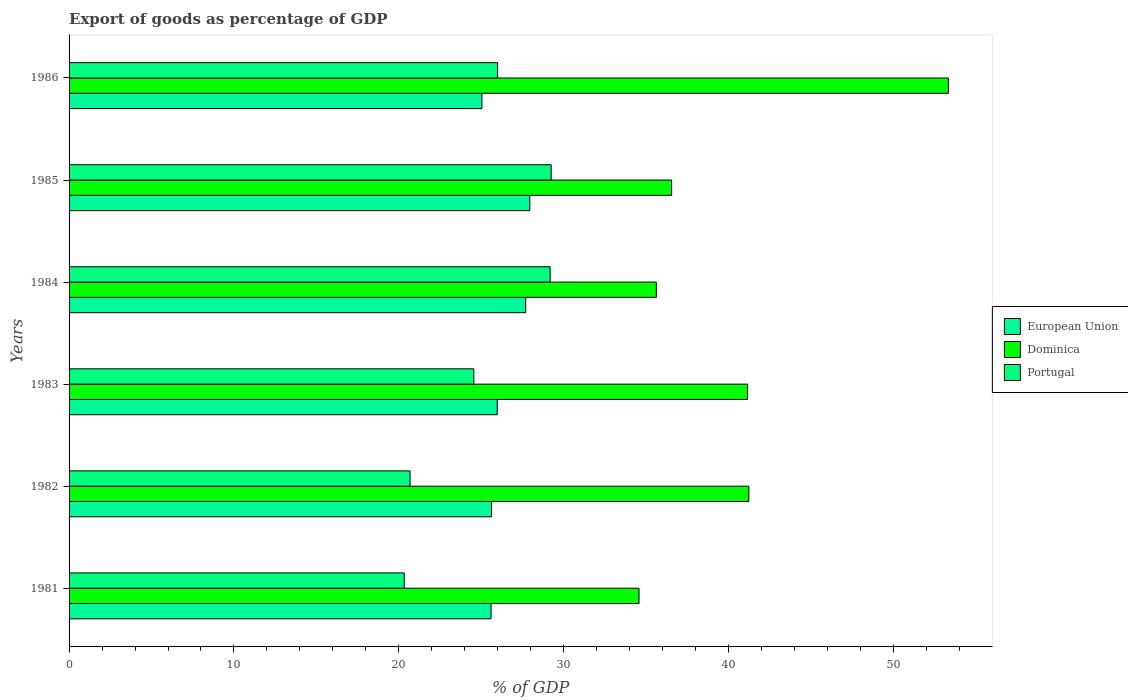How many groups of bars are there?
Your answer should be very brief. 6. Are the number of bars per tick equal to the number of legend labels?
Provide a short and direct response. Yes. Are the number of bars on each tick of the Y-axis equal?
Give a very brief answer. Yes. What is the export of goods as percentage of GDP in Dominica in 1981?
Provide a succinct answer. 34.57. Across all years, what is the maximum export of goods as percentage of GDP in Dominica?
Your response must be concise. 53.33. Across all years, what is the minimum export of goods as percentage of GDP in Portugal?
Keep it short and to the point. 20.33. In which year was the export of goods as percentage of GDP in European Union maximum?
Give a very brief answer. 1985. What is the total export of goods as percentage of GDP in Dominica in the graph?
Your answer should be very brief. 242.43. What is the difference between the export of goods as percentage of GDP in European Union in 1981 and that in 1985?
Make the answer very short. -2.35. What is the difference between the export of goods as percentage of GDP in Portugal in 1985 and the export of goods as percentage of GDP in Dominica in 1983?
Give a very brief answer. -11.91. What is the average export of goods as percentage of GDP in Dominica per year?
Ensure brevity in your answer.  40.4. In the year 1986, what is the difference between the export of goods as percentage of GDP in Portugal and export of goods as percentage of GDP in Dominica?
Offer a very short reply. -27.34. What is the ratio of the export of goods as percentage of GDP in European Union in 1981 to that in 1986?
Offer a terse response. 1.02. What is the difference between the highest and the second highest export of goods as percentage of GDP in Dominica?
Keep it short and to the point. 12.1. What is the difference between the highest and the lowest export of goods as percentage of GDP in European Union?
Offer a terse response. 2.91. Is the sum of the export of goods as percentage of GDP in European Union in 1981 and 1985 greater than the maximum export of goods as percentage of GDP in Dominica across all years?
Ensure brevity in your answer.  Yes. What does the 2nd bar from the top in 1986 represents?
Provide a succinct answer. Dominica. Is it the case that in every year, the sum of the export of goods as percentage of GDP in Portugal and export of goods as percentage of GDP in Dominica is greater than the export of goods as percentage of GDP in European Union?
Offer a terse response. Yes. Are all the bars in the graph horizontal?
Your answer should be compact. Yes. How many years are there in the graph?
Keep it short and to the point. 6. What is the difference between two consecutive major ticks on the X-axis?
Keep it short and to the point. 10. Are the values on the major ticks of X-axis written in scientific E-notation?
Ensure brevity in your answer.  No. What is the title of the graph?
Make the answer very short. Export of goods as percentage of GDP. What is the label or title of the X-axis?
Offer a terse response. % of GDP. What is the % of GDP in European Union in 1981?
Your answer should be very brief. 25.59. What is the % of GDP in Dominica in 1981?
Give a very brief answer. 34.57. What is the % of GDP of Portugal in 1981?
Provide a short and direct response. 20.33. What is the % of GDP of European Union in 1982?
Offer a terse response. 25.62. What is the % of GDP in Dominica in 1982?
Offer a very short reply. 41.23. What is the % of GDP in Portugal in 1982?
Your response must be concise. 20.68. What is the % of GDP in European Union in 1983?
Your response must be concise. 25.97. What is the % of GDP in Dominica in 1983?
Your answer should be compact. 41.15. What is the % of GDP in Portugal in 1983?
Offer a terse response. 24.55. What is the % of GDP in European Union in 1984?
Your answer should be very brief. 27.69. What is the % of GDP in Dominica in 1984?
Offer a very short reply. 35.62. What is the % of GDP in Portugal in 1984?
Give a very brief answer. 29.17. What is the % of GDP in European Union in 1985?
Make the answer very short. 27.94. What is the % of GDP in Dominica in 1985?
Keep it short and to the point. 36.54. What is the % of GDP in Portugal in 1985?
Your response must be concise. 29.24. What is the % of GDP of European Union in 1986?
Your answer should be very brief. 25.04. What is the % of GDP of Dominica in 1986?
Keep it short and to the point. 53.33. What is the % of GDP of Portugal in 1986?
Your response must be concise. 25.99. Across all years, what is the maximum % of GDP of European Union?
Offer a terse response. 27.94. Across all years, what is the maximum % of GDP of Dominica?
Ensure brevity in your answer.  53.33. Across all years, what is the maximum % of GDP of Portugal?
Keep it short and to the point. 29.24. Across all years, what is the minimum % of GDP in European Union?
Make the answer very short. 25.04. Across all years, what is the minimum % of GDP in Dominica?
Provide a short and direct response. 34.57. Across all years, what is the minimum % of GDP of Portugal?
Provide a short and direct response. 20.33. What is the total % of GDP in European Union in the graph?
Your response must be concise. 157.85. What is the total % of GDP of Dominica in the graph?
Your answer should be very brief. 242.43. What is the total % of GDP in Portugal in the graph?
Offer a very short reply. 149.96. What is the difference between the % of GDP in European Union in 1981 and that in 1982?
Provide a short and direct response. -0.03. What is the difference between the % of GDP in Dominica in 1981 and that in 1982?
Provide a short and direct response. -6.66. What is the difference between the % of GDP in Portugal in 1981 and that in 1982?
Ensure brevity in your answer.  -0.35. What is the difference between the % of GDP of European Union in 1981 and that in 1983?
Offer a terse response. -0.37. What is the difference between the % of GDP in Dominica in 1981 and that in 1983?
Keep it short and to the point. -6.58. What is the difference between the % of GDP in Portugal in 1981 and that in 1983?
Ensure brevity in your answer.  -4.22. What is the difference between the % of GDP in European Union in 1981 and that in 1984?
Make the answer very short. -2.1. What is the difference between the % of GDP of Dominica in 1981 and that in 1984?
Offer a terse response. -1.05. What is the difference between the % of GDP in Portugal in 1981 and that in 1984?
Keep it short and to the point. -8.85. What is the difference between the % of GDP in European Union in 1981 and that in 1985?
Your answer should be very brief. -2.35. What is the difference between the % of GDP of Dominica in 1981 and that in 1985?
Offer a terse response. -1.98. What is the difference between the % of GDP of Portugal in 1981 and that in 1985?
Make the answer very short. -8.91. What is the difference between the % of GDP in European Union in 1981 and that in 1986?
Your answer should be very brief. 0.56. What is the difference between the % of GDP of Dominica in 1981 and that in 1986?
Ensure brevity in your answer.  -18.76. What is the difference between the % of GDP in Portugal in 1981 and that in 1986?
Offer a terse response. -5.66. What is the difference between the % of GDP in European Union in 1982 and that in 1983?
Offer a terse response. -0.35. What is the difference between the % of GDP of Dominica in 1982 and that in 1983?
Make the answer very short. 0.08. What is the difference between the % of GDP of Portugal in 1982 and that in 1983?
Make the answer very short. -3.87. What is the difference between the % of GDP in European Union in 1982 and that in 1984?
Offer a terse response. -2.07. What is the difference between the % of GDP in Dominica in 1982 and that in 1984?
Keep it short and to the point. 5.61. What is the difference between the % of GDP in Portugal in 1982 and that in 1984?
Your answer should be very brief. -8.49. What is the difference between the % of GDP in European Union in 1982 and that in 1985?
Offer a terse response. -2.32. What is the difference between the % of GDP of Dominica in 1982 and that in 1985?
Provide a short and direct response. 4.68. What is the difference between the % of GDP of Portugal in 1982 and that in 1985?
Ensure brevity in your answer.  -8.56. What is the difference between the % of GDP of European Union in 1982 and that in 1986?
Offer a very short reply. 0.59. What is the difference between the % of GDP in Dominica in 1982 and that in 1986?
Offer a terse response. -12.1. What is the difference between the % of GDP of Portugal in 1982 and that in 1986?
Offer a terse response. -5.31. What is the difference between the % of GDP in European Union in 1983 and that in 1984?
Provide a short and direct response. -1.72. What is the difference between the % of GDP of Dominica in 1983 and that in 1984?
Provide a short and direct response. 5.53. What is the difference between the % of GDP in Portugal in 1983 and that in 1984?
Provide a succinct answer. -4.63. What is the difference between the % of GDP of European Union in 1983 and that in 1985?
Offer a terse response. -1.98. What is the difference between the % of GDP of Dominica in 1983 and that in 1985?
Your response must be concise. 4.61. What is the difference between the % of GDP in Portugal in 1983 and that in 1985?
Make the answer very short. -4.69. What is the difference between the % of GDP of European Union in 1983 and that in 1986?
Your answer should be compact. 0.93. What is the difference between the % of GDP of Dominica in 1983 and that in 1986?
Provide a succinct answer. -12.18. What is the difference between the % of GDP in Portugal in 1983 and that in 1986?
Your response must be concise. -1.44. What is the difference between the % of GDP of European Union in 1984 and that in 1985?
Your answer should be very brief. -0.25. What is the difference between the % of GDP in Dominica in 1984 and that in 1985?
Give a very brief answer. -0.93. What is the difference between the % of GDP of Portugal in 1984 and that in 1985?
Your answer should be very brief. -0.06. What is the difference between the % of GDP in European Union in 1984 and that in 1986?
Give a very brief answer. 2.66. What is the difference between the % of GDP of Dominica in 1984 and that in 1986?
Provide a succinct answer. -17.71. What is the difference between the % of GDP in Portugal in 1984 and that in 1986?
Provide a succinct answer. 3.18. What is the difference between the % of GDP of European Union in 1985 and that in 1986?
Your answer should be compact. 2.91. What is the difference between the % of GDP of Dominica in 1985 and that in 1986?
Offer a very short reply. -16.78. What is the difference between the % of GDP of Portugal in 1985 and that in 1986?
Provide a short and direct response. 3.25. What is the difference between the % of GDP in European Union in 1981 and the % of GDP in Dominica in 1982?
Make the answer very short. -15.63. What is the difference between the % of GDP in European Union in 1981 and the % of GDP in Portugal in 1982?
Offer a terse response. 4.91. What is the difference between the % of GDP in Dominica in 1981 and the % of GDP in Portugal in 1982?
Your answer should be very brief. 13.89. What is the difference between the % of GDP of European Union in 1981 and the % of GDP of Dominica in 1983?
Provide a succinct answer. -15.56. What is the difference between the % of GDP in European Union in 1981 and the % of GDP in Portugal in 1983?
Offer a terse response. 1.05. What is the difference between the % of GDP of Dominica in 1981 and the % of GDP of Portugal in 1983?
Offer a terse response. 10.02. What is the difference between the % of GDP in European Union in 1981 and the % of GDP in Dominica in 1984?
Keep it short and to the point. -10.02. What is the difference between the % of GDP in European Union in 1981 and the % of GDP in Portugal in 1984?
Offer a very short reply. -3.58. What is the difference between the % of GDP in Dominica in 1981 and the % of GDP in Portugal in 1984?
Your response must be concise. 5.39. What is the difference between the % of GDP of European Union in 1981 and the % of GDP of Dominica in 1985?
Your response must be concise. -10.95. What is the difference between the % of GDP in European Union in 1981 and the % of GDP in Portugal in 1985?
Your answer should be compact. -3.64. What is the difference between the % of GDP in Dominica in 1981 and the % of GDP in Portugal in 1985?
Offer a terse response. 5.33. What is the difference between the % of GDP in European Union in 1981 and the % of GDP in Dominica in 1986?
Your answer should be compact. -27.73. What is the difference between the % of GDP in European Union in 1981 and the % of GDP in Portugal in 1986?
Keep it short and to the point. -0.4. What is the difference between the % of GDP of Dominica in 1981 and the % of GDP of Portugal in 1986?
Give a very brief answer. 8.57. What is the difference between the % of GDP in European Union in 1982 and the % of GDP in Dominica in 1983?
Give a very brief answer. -15.53. What is the difference between the % of GDP of European Union in 1982 and the % of GDP of Portugal in 1983?
Keep it short and to the point. 1.07. What is the difference between the % of GDP of Dominica in 1982 and the % of GDP of Portugal in 1983?
Your response must be concise. 16.68. What is the difference between the % of GDP in European Union in 1982 and the % of GDP in Dominica in 1984?
Keep it short and to the point. -9.99. What is the difference between the % of GDP of European Union in 1982 and the % of GDP of Portugal in 1984?
Ensure brevity in your answer.  -3.55. What is the difference between the % of GDP of Dominica in 1982 and the % of GDP of Portugal in 1984?
Your answer should be very brief. 12.05. What is the difference between the % of GDP in European Union in 1982 and the % of GDP in Dominica in 1985?
Give a very brief answer. -10.92. What is the difference between the % of GDP in European Union in 1982 and the % of GDP in Portugal in 1985?
Make the answer very short. -3.62. What is the difference between the % of GDP of Dominica in 1982 and the % of GDP of Portugal in 1985?
Make the answer very short. 11.99. What is the difference between the % of GDP in European Union in 1982 and the % of GDP in Dominica in 1986?
Your response must be concise. -27.71. What is the difference between the % of GDP of European Union in 1982 and the % of GDP of Portugal in 1986?
Your answer should be very brief. -0.37. What is the difference between the % of GDP of Dominica in 1982 and the % of GDP of Portugal in 1986?
Offer a terse response. 15.23. What is the difference between the % of GDP in European Union in 1983 and the % of GDP in Dominica in 1984?
Your answer should be compact. -9.65. What is the difference between the % of GDP in European Union in 1983 and the % of GDP in Portugal in 1984?
Provide a succinct answer. -3.21. What is the difference between the % of GDP of Dominica in 1983 and the % of GDP of Portugal in 1984?
Give a very brief answer. 11.97. What is the difference between the % of GDP of European Union in 1983 and the % of GDP of Dominica in 1985?
Provide a short and direct response. -10.58. What is the difference between the % of GDP in European Union in 1983 and the % of GDP in Portugal in 1985?
Offer a terse response. -3.27. What is the difference between the % of GDP of Dominica in 1983 and the % of GDP of Portugal in 1985?
Make the answer very short. 11.91. What is the difference between the % of GDP of European Union in 1983 and the % of GDP of Dominica in 1986?
Offer a very short reply. -27.36. What is the difference between the % of GDP of European Union in 1983 and the % of GDP of Portugal in 1986?
Offer a terse response. -0.02. What is the difference between the % of GDP of Dominica in 1983 and the % of GDP of Portugal in 1986?
Offer a terse response. 15.16. What is the difference between the % of GDP in European Union in 1984 and the % of GDP in Dominica in 1985?
Offer a terse response. -8.85. What is the difference between the % of GDP in European Union in 1984 and the % of GDP in Portugal in 1985?
Your answer should be compact. -1.55. What is the difference between the % of GDP in Dominica in 1984 and the % of GDP in Portugal in 1985?
Offer a terse response. 6.38. What is the difference between the % of GDP of European Union in 1984 and the % of GDP of Dominica in 1986?
Make the answer very short. -25.64. What is the difference between the % of GDP in European Union in 1984 and the % of GDP in Portugal in 1986?
Give a very brief answer. 1.7. What is the difference between the % of GDP in Dominica in 1984 and the % of GDP in Portugal in 1986?
Your answer should be compact. 9.62. What is the difference between the % of GDP of European Union in 1985 and the % of GDP of Dominica in 1986?
Keep it short and to the point. -25.39. What is the difference between the % of GDP in European Union in 1985 and the % of GDP in Portugal in 1986?
Ensure brevity in your answer.  1.95. What is the difference between the % of GDP of Dominica in 1985 and the % of GDP of Portugal in 1986?
Ensure brevity in your answer.  10.55. What is the average % of GDP in European Union per year?
Ensure brevity in your answer.  26.31. What is the average % of GDP of Dominica per year?
Make the answer very short. 40.4. What is the average % of GDP of Portugal per year?
Your response must be concise. 24.99. In the year 1981, what is the difference between the % of GDP in European Union and % of GDP in Dominica?
Your answer should be very brief. -8.97. In the year 1981, what is the difference between the % of GDP in European Union and % of GDP in Portugal?
Your answer should be very brief. 5.27. In the year 1981, what is the difference between the % of GDP of Dominica and % of GDP of Portugal?
Provide a short and direct response. 14.24. In the year 1982, what is the difference between the % of GDP of European Union and % of GDP of Dominica?
Offer a terse response. -15.6. In the year 1982, what is the difference between the % of GDP in European Union and % of GDP in Portugal?
Give a very brief answer. 4.94. In the year 1982, what is the difference between the % of GDP in Dominica and % of GDP in Portugal?
Provide a succinct answer. 20.55. In the year 1983, what is the difference between the % of GDP of European Union and % of GDP of Dominica?
Offer a terse response. -15.18. In the year 1983, what is the difference between the % of GDP in European Union and % of GDP in Portugal?
Your response must be concise. 1.42. In the year 1983, what is the difference between the % of GDP of Dominica and % of GDP of Portugal?
Your response must be concise. 16.6. In the year 1984, what is the difference between the % of GDP of European Union and % of GDP of Dominica?
Provide a short and direct response. -7.92. In the year 1984, what is the difference between the % of GDP in European Union and % of GDP in Portugal?
Your answer should be very brief. -1.48. In the year 1984, what is the difference between the % of GDP of Dominica and % of GDP of Portugal?
Your answer should be very brief. 6.44. In the year 1985, what is the difference between the % of GDP of European Union and % of GDP of Dominica?
Keep it short and to the point. -8.6. In the year 1985, what is the difference between the % of GDP in European Union and % of GDP in Portugal?
Ensure brevity in your answer.  -1.3. In the year 1985, what is the difference between the % of GDP of Dominica and % of GDP of Portugal?
Offer a terse response. 7.31. In the year 1986, what is the difference between the % of GDP of European Union and % of GDP of Dominica?
Offer a terse response. -28.29. In the year 1986, what is the difference between the % of GDP of European Union and % of GDP of Portugal?
Your answer should be compact. -0.95. In the year 1986, what is the difference between the % of GDP in Dominica and % of GDP in Portugal?
Give a very brief answer. 27.34. What is the ratio of the % of GDP in Dominica in 1981 to that in 1982?
Keep it short and to the point. 0.84. What is the ratio of the % of GDP of Portugal in 1981 to that in 1982?
Make the answer very short. 0.98. What is the ratio of the % of GDP of European Union in 1981 to that in 1983?
Your answer should be very brief. 0.99. What is the ratio of the % of GDP in Dominica in 1981 to that in 1983?
Offer a terse response. 0.84. What is the ratio of the % of GDP of Portugal in 1981 to that in 1983?
Your answer should be compact. 0.83. What is the ratio of the % of GDP of European Union in 1981 to that in 1984?
Offer a very short reply. 0.92. What is the ratio of the % of GDP of Dominica in 1981 to that in 1984?
Provide a short and direct response. 0.97. What is the ratio of the % of GDP of Portugal in 1981 to that in 1984?
Ensure brevity in your answer.  0.7. What is the ratio of the % of GDP of European Union in 1981 to that in 1985?
Keep it short and to the point. 0.92. What is the ratio of the % of GDP of Dominica in 1981 to that in 1985?
Provide a succinct answer. 0.95. What is the ratio of the % of GDP of Portugal in 1981 to that in 1985?
Your response must be concise. 0.7. What is the ratio of the % of GDP of European Union in 1981 to that in 1986?
Your response must be concise. 1.02. What is the ratio of the % of GDP in Dominica in 1981 to that in 1986?
Give a very brief answer. 0.65. What is the ratio of the % of GDP of Portugal in 1981 to that in 1986?
Provide a short and direct response. 0.78. What is the ratio of the % of GDP in European Union in 1982 to that in 1983?
Provide a short and direct response. 0.99. What is the ratio of the % of GDP in Portugal in 1982 to that in 1983?
Keep it short and to the point. 0.84. What is the ratio of the % of GDP of European Union in 1982 to that in 1984?
Keep it short and to the point. 0.93. What is the ratio of the % of GDP of Dominica in 1982 to that in 1984?
Your response must be concise. 1.16. What is the ratio of the % of GDP of Portugal in 1982 to that in 1984?
Your response must be concise. 0.71. What is the ratio of the % of GDP of European Union in 1982 to that in 1985?
Offer a very short reply. 0.92. What is the ratio of the % of GDP of Dominica in 1982 to that in 1985?
Your answer should be compact. 1.13. What is the ratio of the % of GDP of Portugal in 1982 to that in 1985?
Give a very brief answer. 0.71. What is the ratio of the % of GDP in European Union in 1982 to that in 1986?
Keep it short and to the point. 1.02. What is the ratio of the % of GDP in Dominica in 1982 to that in 1986?
Provide a short and direct response. 0.77. What is the ratio of the % of GDP of Portugal in 1982 to that in 1986?
Provide a short and direct response. 0.8. What is the ratio of the % of GDP in European Union in 1983 to that in 1984?
Offer a very short reply. 0.94. What is the ratio of the % of GDP in Dominica in 1983 to that in 1984?
Ensure brevity in your answer.  1.16. What is the ratio of the % of GDP of Portugal in 1983 to that in 1984?
Ensure brevity in your answer.  0.84. What is the ratio of the % of GDP in European Union in 1983 to that in 1985?
Give a very brief answer. 0.93. What is the ratio of the % of GDP in Dominica in 1983 to that in 1985?
Ensure brevity in your answer.  1.13. What is the ratio of the % of GDP of Portugal in 1983 to that in 1985?
Your answer should be very brief. 0.84. What is the ratio of the % of GDP in European Union in 1983 to that in 1986?
Make the answer very short. 1.04. What is the ratio of the % of GDP in Dominica in 1983 to that in 1986?
Offer a terse response. 0.77. What is the ratio of the % of GDP of Portugal in 1983 to that in 1986?
Provide a succinct answer. 0.94. What is the ratio of the % of GDP in European Union in 1984 to that in 1985?
Keep it short and to the point. 0.99. What is the ratio of the % of GDP in Dominica in 1984 to that in 1985?
Keep it short and to the point. 0.97. What is the ratio of the % of GDP of European Union in 1984 to that in 1986?
Provide a succinct answer. 1.11. What is the ratio of the % of GDP in Dominica in 1984 to that in 1986?
Offer a terse response. 0.67. What is the ratio of the % of GDP of Portugal in 1984 to that in 1986?
Your response must be concise. 1.12. What is the ratio of the % of GDP in European Union in 1985 to that in 1986?
Provide a succinct answer. 1.12. What is the ratio of the % of GDP of Dominica in 1985 to that in 1986?
Offer a terse response. 0.69. What is the ratio of the % of GDP of Portugal in 1985 to that in 1986?
Give a very brief answer. 1.12. What is the difference between the highest and the second highest % of GDP in European Union?
Provide a succinct answer. 0.25. What is the difference between the highest and the second highest % of GDP of Dominica?
Provide a short and direct response. 12.1. What is the difference between the highest and the second highest % of GDP in Portugal?
Your answer should be compact. 0.06. What is the difference between the highest and the lowest % of GDP in European Union?
Provide a succinct answer. 2.91. What is the difference between the highest and the lowest % of GDP in Dominica?
Your response must be concise. 18.76. What is the difference between the highest and the lowest % of GDP of Portugal?
Your answer should be compact. 8.91. 